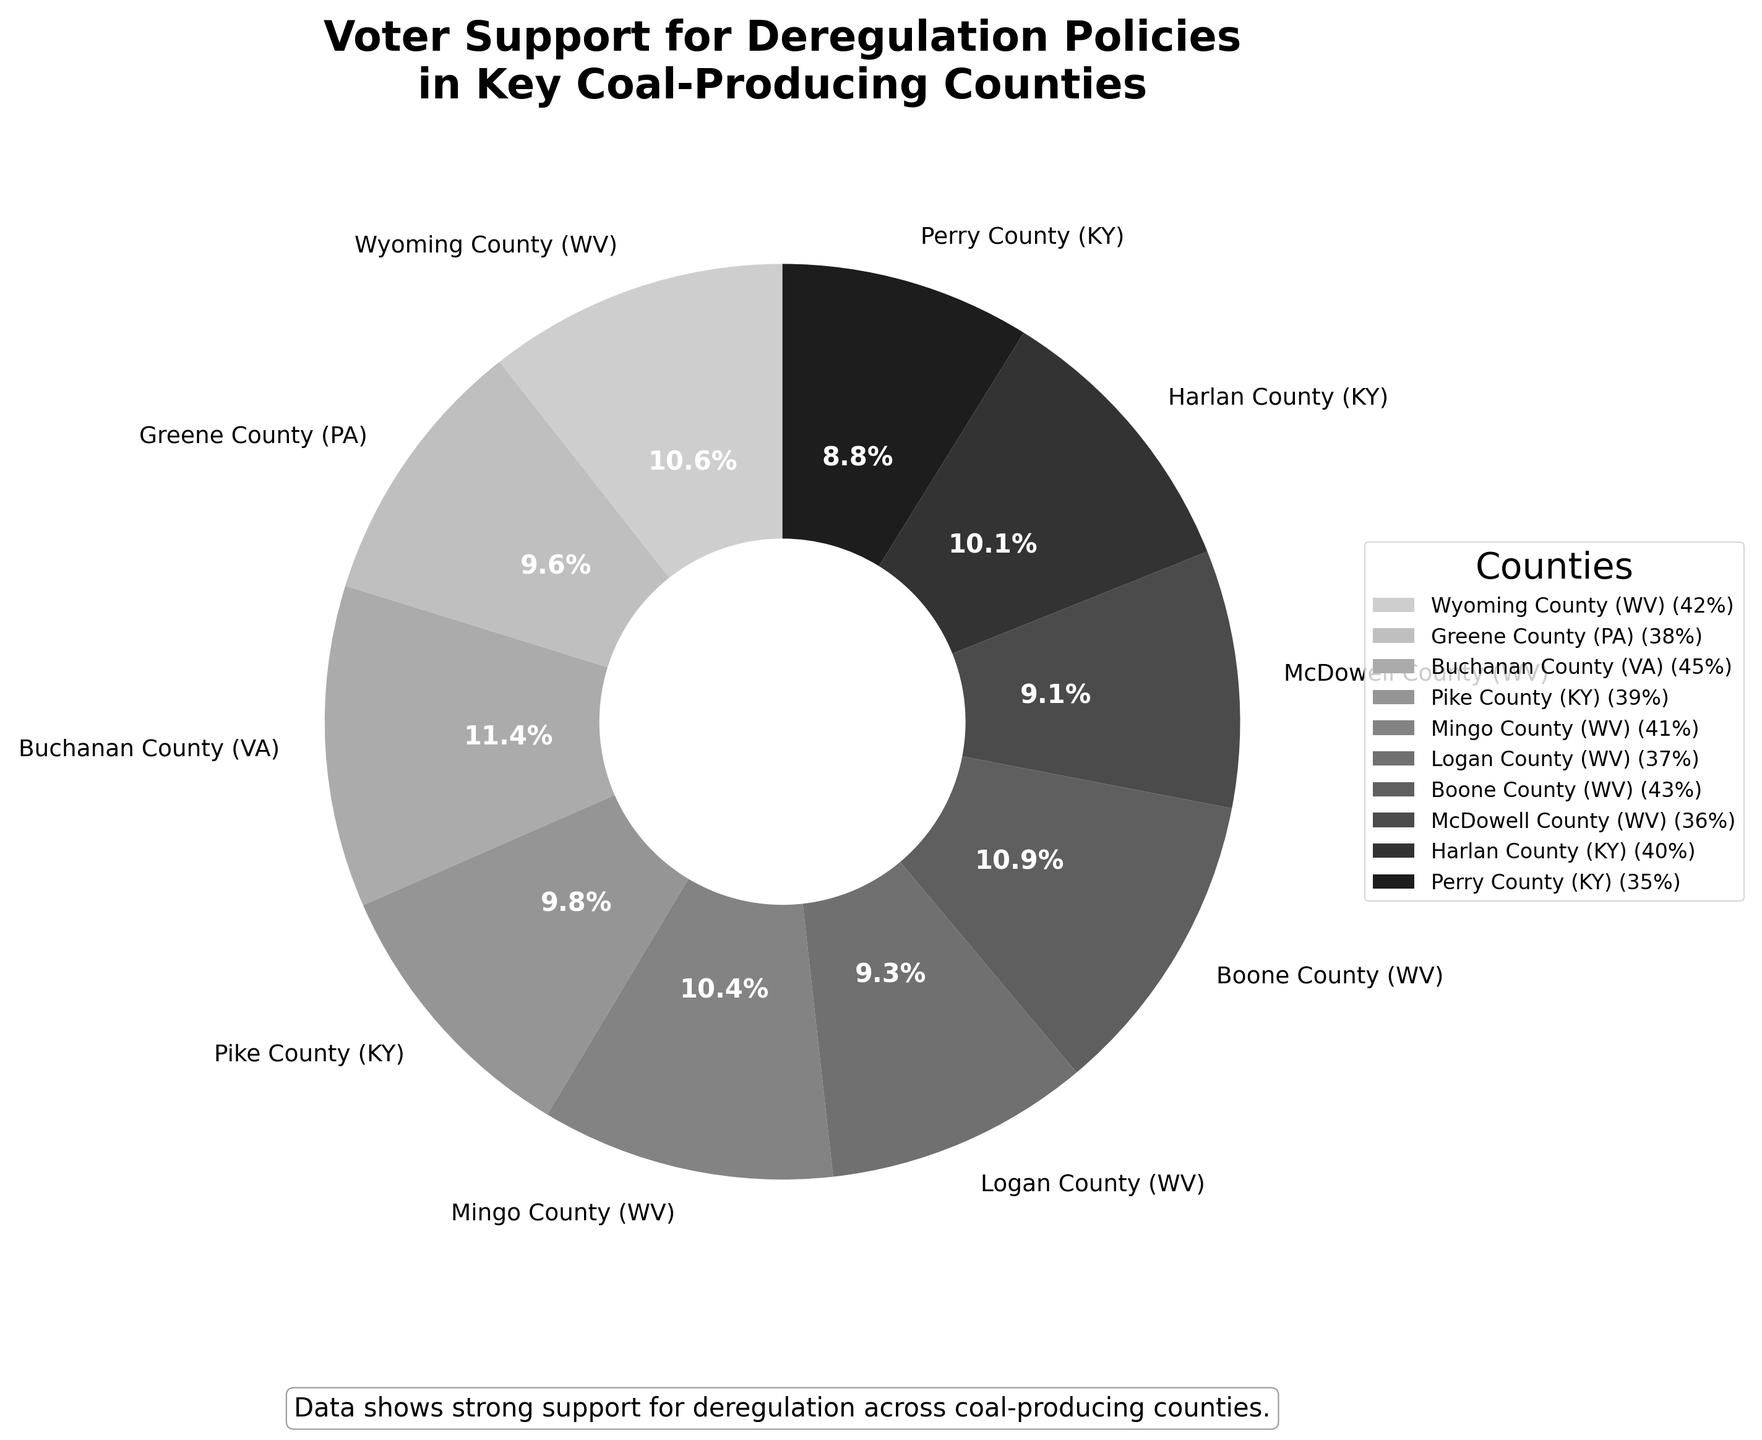Which county has the highest voter support for deregulation policies? Look at the pie chart to identify the county with the largest wedge, which correlates to the highest percentage. Buchanan County (VA) has the highest voter support with 45%.
Answer: Buchanan County (VA) Which three counties have the lowest voter support for deregulation policies? Identify the counties with the smallest wedges or smallest percentages in the pie chart. The three counties with the lowest support are Perry County (KY) at 35%, McDowell County (WV) at 36%, and Logan County (WV) at 37%.
Answer: Perry County (KY), McDowell County (WV), Logan County (WV) What is the total percentage of voter support for deregulation policies in West Virginia counties? Identify the counties located in West Virginia, sum their percentages: (42% from Wyoming) + (41% from Mingo) + (37% from Logan) + (43% from Boone) + (36% from McDowell) = 199%.
Answer: 199% Which county has more voter support for deregulation policies: Greene County (PA) or Pike County (KY)? Compare the percentages for Greene and Pike Counties in the pie chart. Greene County (PA) has 38%, while Pike County (KY) has 39%. Therefore, Pike County has more support.
Answer: Pike County (KY) How much more voter support does Buchanan County (VA) have compared to McDowell County (WV)? Subtract the support percentage of McDowell County (36%) from that of Buchanan County (45%): 45% - 36% = 9%.
Answer: 9% Which counties have voter support percentages that are equal to or greater than 40%? Identify the wedges in the pie chart where the percentages are 40% or higher. These counties are Buchanan County (VA) with 45%, Wyoming County (WV) with 42%, Boone County (WV) with 43%, Mingo County (WV) with 41%, and Harlan County (KY) with 40%.
Answer: Buchanan County (VA), Wyoming County (WV), Boone County (WV), Mingo County (WV), Harlan County (KY) What's the average voter support percentage for deregulation policies across all counties? Sum all the percentages and divide by the number of counties: (42+38+45+39+41+37+43+36+40+35)/10 = 39.6%.
Answer: 39.6% Are there more counties with voter support above or below 40%? Count the number of counties with support above 40% and those below 40%. Above 40%: 5 counties, Below 40%: 5 counties.
Answer: Same amount Which county has a similar voter support percentage to Greene County (PA)? Identify the percentage of Greene County (38%) and find other counties with similar values. The closest values are Logan County (WV) with 37% and Pike County (KY) with 39%.
Answer: Logan County (WV), Pike County (KY) Among Kentucky counties, which one has the lowest voter support for deregulation policies? Compare the voter support percentages of all counties in Kentucky. The Kentucky counties are Pike (39%), Harlan (40%), and Perry (35%). The lowest is Perry County (35%).
Answer: Perry County (KY) 